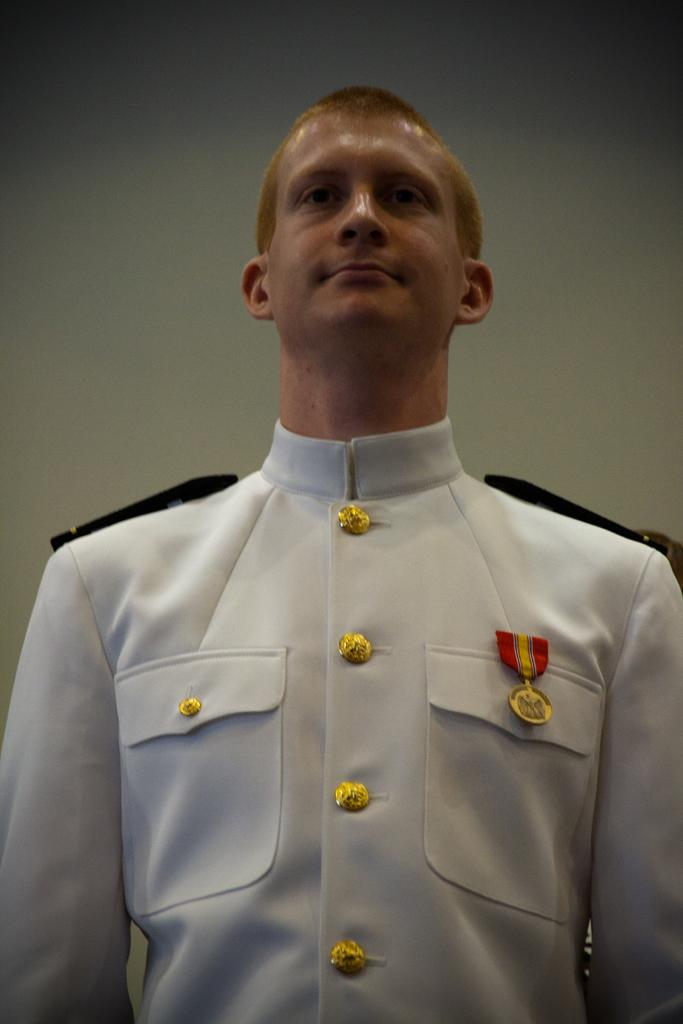What is the main subject of the picture? The main subject of the picture is a man standing. Can you describe any notable features of the man? The man has a medal on his pocket. What is the color of the background in the image? The background of the image is white. Where is the sink located in the image? There is no sink present in the image. What type of nerve is visible in the image? There is no nerve visible in the image. 